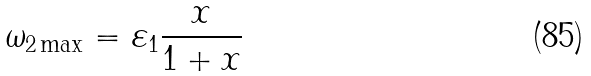<formula> <loc_0><loc_0><loc_500><loc_500>\omega _ { 2 \max } = \varepsilon _ { 1 } \frac { x } { 1 + x }</formula> 